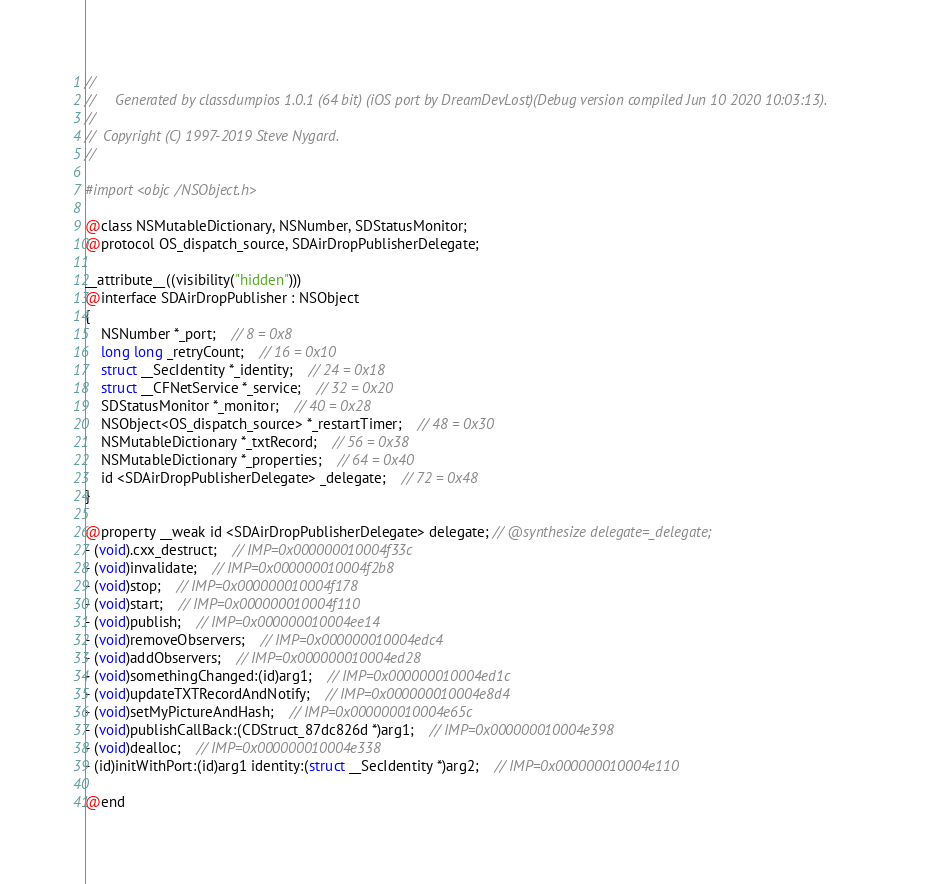Convert code to text. <code><loc_0><loc_0><loc_500><loc_500><_C_>//
//     Generated by classdumpios 1.0.1 (64 bit) (iOS port by DreamDevLost)(Debug version compiled Jun 10 2020 10:03:13).
//
//  Copyright (C) 1997-2019 Steve Nygard.
//

#import <objc/NSObject.h>

@class NSMutableDictionary, NSNumber, SDStatusMonitor;
@protocol OS_dispatch_source, SDAirDropPublisherDelegate;

__attribute__((visibility("hidden")))
@interface SDAirDropPublisher : NSObject
{
    NSNumber *_port;	// 8 = 0x8
    long long _retryCount;	// 16 = 0x10
    struct __SecIdentity *_identity;	// 24 = 0x18
    struct __CFNetService *_service;	// 32 = 0x20
    SDStatusMonitor *_monitor;	// 40 = 0x28
    NSObject<OS_dispatch_source> *_restartTimer;	// 48 = 0x30
    NSMutableDictionary *_txtRecord;	// 56 = 0x38
    NSMutableDictionary *_properties;	// 64 = 0x40
    id <SDAirDropPublisherDelegate> _delegate;	// 72 = 0x48
}

@property __weak id <SDAirDropPublisherDelegate> delegate; // @synthesize delegate=_delegate;
- (void).cxx_destruct;	// IMP=0x000000010004f33c
- (void)invalidate;	// IMP=0x000000010004f2b8
- (void)stop;	// IMP=0x000000010004f178
- (void)start;	// IMP=0x000000010004f110
- (void)publish;	// IMP=0x000000010004ee14
- (void)removeObservers;	// IMP=0x000000010004edc4
- (void)addObservers;	// IMP=0x000000010004ed28
- (void)somethingChanged:(id)arg1;	// IMP=0x000000010004ed1c
- (void)updateTXTRecordAndNotify;	// IMP=0x000000010004e8d4
- (void)setMyPictureAndHash;	// IMP=0x000000010004e65c
- (void)publishCallBack:(CDStruct_87dc826d *)arg1;	// IMP=0x000000010004e398
- (void)dealloc;	// IMP=0x000000010004e338
- (id)initWithPort:(id)arg1 identity:(struct __SecIdentity *)arg2;	// IMP=0x000000010004e110

@end

</code> 